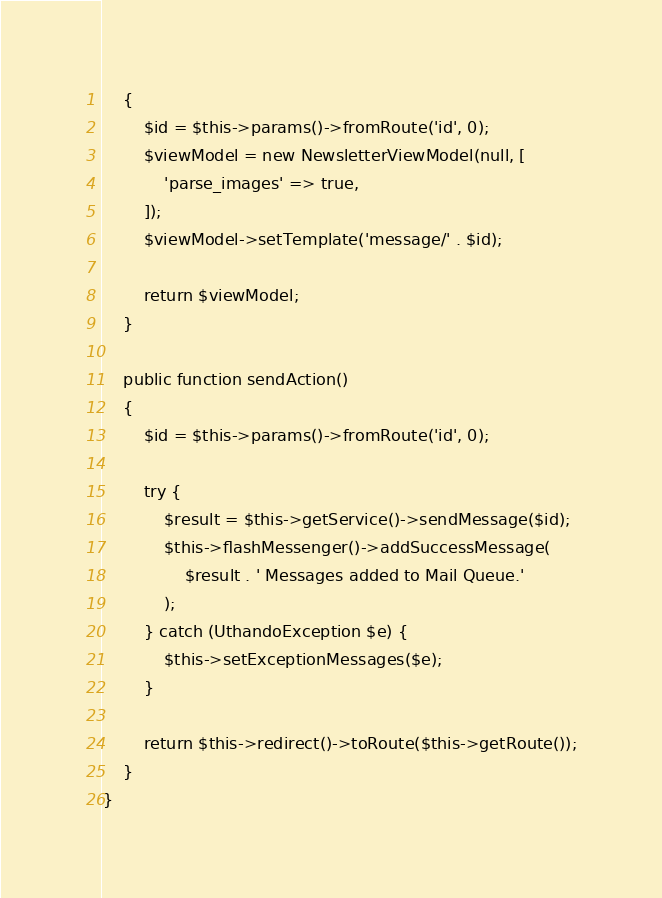Convert code to text. <code><loc_0><loc_0><loc_500><loc_500><_PHP_>    {
        $id = $this->params()->fromRoute('id', 0);
        $viewModel = new NewsletterViewModel(null, [
            'parse_images' => true,
        ]);
        $viewModel->setTemplate('message/' . $id);

        return $viewModel;
    }

    public function sendAction()
    {
        $id = $this->params()->fromRoute('id', 0);

        try {
            $result = $this->getService()->sendMessage($id);
            $this->flashMessenger()->addSuccessMessage(
                $result . ' Messages added to Mail Queue.'
            );
        } catch (UthandoException $e) {
            $this->setExceptionMessages($e);
        }
        
        return $this->redirect()->toRoute($this->getRoute());
    }
}</code> 